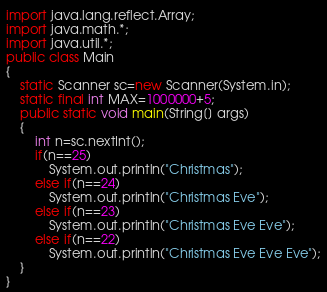Convert code to text. <code><loc_0><loc_0><loc_500><loc_500><_Java_>import java.lang.reflect.Array;
import java.math.*;
import java.util.*;
public class Main
{
	static Scanner sc=new Scanner(System.in);
	static final int MAX=1000000+5;
	public static void main(String[] args)
	{
		int n=sc.nextInt();
		if(n==25)
			System.out.println("Christmas");
		else if(n==24)
			System.out.println("Christmas Eve");
		else if(n==23)
			System.out.println("Christmas Eve Eve");
		else if(n==22)
			System.out.println("Christmas Eve Eve Eve");
	}
}</code> 